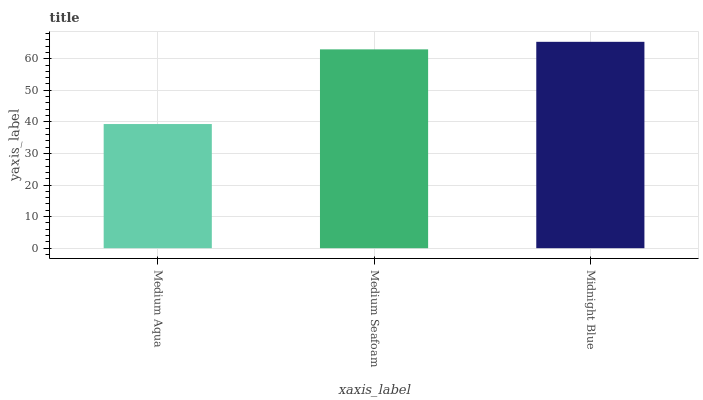Is Medium Aqua the minimum?
Answer yes or no. Yes. Is Midnight Blue the maximum?
Answer yes or no. Yes. Is Medium Seafoam the minimum?
Answer yes or no. No. Is Medium Seafoam the maximum?
Answer yes or no. No. Is Medium Seafoam greater than Medium Aqua?
Answer yes or no. Yes. Is Medium Aqua less than Medium Seafoam?
Answer yes or no. Yes. Is Medium Aqua greater than Medium Seafoam?
Answer yes or no. No. Is Medium Seafoam less than Medium Aqua?
Answer yes or no. No. Is Medium Seafoam the high median?
Answer yes or no. Yes. Is Medium Seafoam the low median?
Answer yes or no. Yes. Is Medium Aqua the high median?
Answer yes or no. No. Is Midnight Blue the low median?
Answer yes or no. No. 